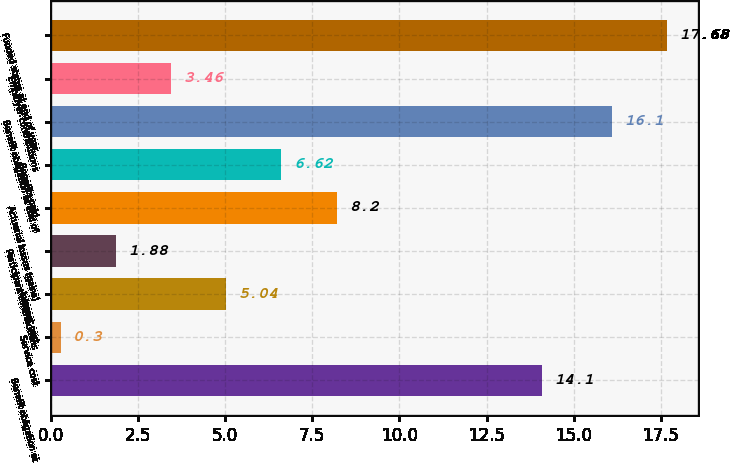<chart> <loc_0><loc_0><loc_500><loc_500><bar_chart><fcel>Benefit obligation at<fcel>Service cost<fcel>Interest cost<fcel>Participant contributions<fcel>Actuarial losses (gains)<fcel>Benefits paid<fcel>Benefit obligation at end of<fcel>Employer contributions<fcel>Funded status at end of year<nl><fcel>14.1<fcel>0.3<fcel>5.04<fcel>1.88<fcel>8.2<fcel>6.62<fcel>16.1<fcel>3.46<fcel>17.68<nl></chart> 